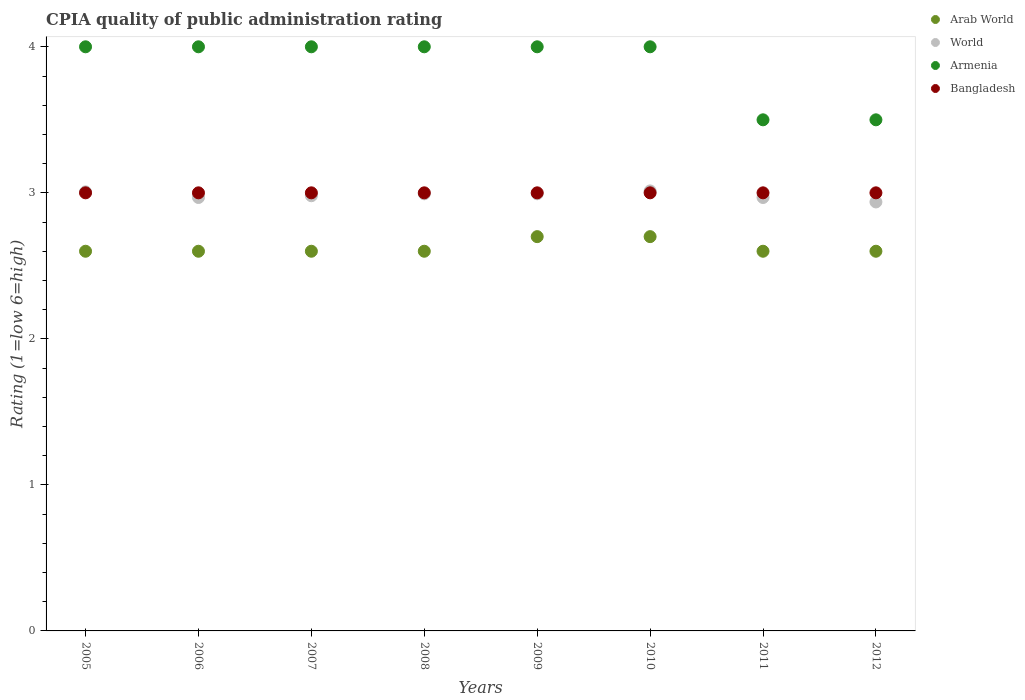How many different coloured dotlines are there?
Your answer should be compact. 4. Is the number of dotlines equal to the number of legend labels?
Give a very brief answer. Yes. What is the CPIA rating in Arab World in 2008?
Keep it short and to the point. 2.6. Across all years, what is the maximum CPIA rating in Bangladesh?
Ensure brevity in your answer.  3. What is the total CPIA rating in Arab World in the graph?
Offer a very short reply. 21. What is the difference between the CPIA rating in Bangladesh in 2006 and that in 2010?
Your answer should be compact. 0. What is the average CPIA rating in Arab World per year?
Keep it short and to the point. 2.62. In the year 2007, what is the difference between the CPIA rating in Bangladesh and CPIA rating in World?
Your response must be concise. 0.02. In how many years, is the CPIA rating in World greater than 3.4?
Your answer should be compact. 0. What is the ratio of the CPIA rating in World in 2005 to that in 2009?
Your answer should be very brief. 1. Is the CPIA rating in Armenia in 2007 less than that in 2010?
Offer a very short reply. No. What is the difference between the highest and the lowest CPIA rating in Bangladesh?
Ensure brevity in your answer.  0. In how many years, is the CPIA rating in Armenia greater than the average CPIA rating in Armenia taken over all years?
Make the answer very short. 6. Is the sum of the CPIA rating in Bangladesh in 2007 and 2012 greater than the maximum CPIA rating in Arab World across all years?
Your answer should be compact. Yes. Is it the case that in every year, the sum of the CPIA rating in Bangladesh and CPIA rating in World  is greater than the sum of CPIA rating in Arab World and CPIA rating in Armenia?
Make the answer very short. Yes. Does the CPIA rating in Arab World monotonically increase over the years?
Your answer should be compact. No. What is the difference between two consecutive major ticks on the Y-axis?
Offer a very short reply. 1. Where does the legend appear in the graph?
Keep it short and to the point. Top right. How many legend labels are there?
Your answer should be compact. 4. What is the title of the graph?
Keep it short and to the point. CPIA quality of public administration rating. Does "Costa Rica" appear as one of the legend labels in the graph?
Give a very brief answer. No. What is the label or title of the Y-axis?
Your response must be concise. Rating (1=low 6=high). What is the Rating (1=low 6=high) in Arab World in 2005?
Your answer should be very brief. 2.6. What is the Rating (1=low 6=high) of World in 2005?
Provide a short and direct response. 3.01. What is the Rating (1=low 6=high) in Armenia in 2005?
Provide a succinct answer. 4. What is the Rating (1=low 6=high) of World in 2006?
Your answer should be very brief. 2.97. What is the Rating (1=low 6=high) in Armenia in 2006?
Offer a very short reply. 4. What is the Rating (1=low 6=high) in Bangladesh in 2006?
Offer a terse response. 3. What is the Rating (1=low 6=high) in World in 2007?
Offer a very short reply. 2.98. What is the Rating (1=low 6=high) in Arab World in 2008?
Ensure brevity in your answer.  2.6. What is the Rating (1=low 6=high) of World in 2008?
Your answer should be very brief. 2.99. What is the Rating (1=low 6=high) of Armenia in 2008?
Your response must be concise. 4. What is the Rating (1=low 6=high) of World in 2009?
Provide a succinct answer. 2.99. What is the Rating (1=low 6=high) in Arab World in 2010?
Provide a succinct answer. 2.7. What is the Rating (1=low 6=high) in World in 2010?
Your answer should be very brief. 3.01. What is the Rating (1=low 6=high) in Bangladesh in 2010?
Offer a very short reply. 3. What is the Rating (1=low 6=high) in Arab World in 2011?
Your answer should be compact. 2.6. What is the Rating (1=low 6=high) in World in 2011?
Your answer should be compact. 2.97. What is the Rating (1=low 6=high) in Bangladesh in 2011?
Give a very brief answer. 3. What is the Rating (1=low 6=high) in Arab World in 2012?
Provide a succinct answer. 2.6. What is the Rating (1=low 6=high) in World in 2012?
Ensure brevity in your answer.  2.94. What is the Rating (1=low 6=high) in Armenia in 2012?
Keep it short and to the point. 3.5. What is the Rating (1=low 6=high) in Bangladesh in 2012?
Offer a very short reply. 3. Across all years, what is the maximum Rating (1=low 6=high) of Arab World?
Your answer should be compact. 2.7. Across all years, what is the maximum Rating (1=low 6=high) in World?
Your answer should be very brief. 3.01. Across all years, what is the maximum Rating (1=low 6=high) of Armenia?
Your response must be concise. 4. Across all years, what is the minimum Rating (1=low 6=high) of World?
Make the answer very short. 2.94. What is the total Rating (1=low 6=high) of Arab World in the graph?
Your answer should be very brief. 21. What is the total Rating (1=low 6=high) of World in the graph?
Your answer should be compact. 23.86. What is the total Rating (1=low 6=high) in Armenia in the graph?
Your response must be concise. 31. What is the total Rating (1=low 6=high) of Bangladesh in the graph?
Ensure brevity in your answer.  24. What is the difference between the Rating (1=low 6=high) in Arab World in 2005 and that in 2006?
Keep it short and to the point. 0. What is the difference between the Rating (1=low 6=high) of World in 2005 and that in 2006?
Keep it short and to the point. 0.04. What is the difference between the Rating (1=low 6=high) of Armenia in 2005 and that in 2006?
Your answer should be compact. 0. What is the difference between the Rating (1=low 6=high) of Bangladesh in 2005 and that in 2006?
Offer a terse response. 0. What is the difference between the Rating (1=low 6=high) of World in 2005 and that in 2007?
Keep it short and to the point. 0.03. What is the difference between the Rating (1=low 6=high) in Arab World in 2005 and that in 2008?
Provide a short and direct response. 0. What is the difference between the Rating (1=low 6=high) of World in 2005 and that in 2008?
Your answer should be very brief. 0.01. What is the difference between the Rating (1=low 6=high) of Armenia in 2005 and that in 2008?
Ensure brevity in your answer.  0. What is the difference between the Rating (1=low 6=high) in Bangladesh in 2005 and that in 2008?
Ensure brevity in your answer.  0. What is the difference between the Rating (1=low 6=high) of World in 2005 and that in 2009?
Provide a short and direct response. 0.01. What is the difference between the Rating (1=low 6=high) in Armenia in 2005 and that in 2009?
Provide a short and direct response. 0. What is the difference between the Rating (1=low 6=high) in Bangladesh in 2005 and that in 2009?
Make the answer very short. 0. What is the difference between the Rating (1=low 6=high) in World in 2005 and that in 2010?
Keep it short and to the point. -0.01. What is the difference between the Rating (1=low 6=high) of Bangladesh in 2005 and that in 2010?
Make the answer very short. 0. What is the difference between the Rating (1=low 6=high) in Arab World in 2005 and that in 2011?
Offer a terse response. 0. What is the difference between the Rating (1=low 6=high) of World in 2005 and that in 2011?
Make the answer very short. 0.04. What is the difference between the Rating (1=low 6=high) of Armenia in 2005 and that in 2011?
Offer a terse response. 0.5. What is the difference between the Rating (1=low 6=high) in Bangladesh in 2005 and that in 2011?
Ensure brevity in your answer.  0. What is the difference between the Rating (1=low 6=high) of Arab World in 2005 and that in 2012?
Your response must be concise. 0. What is the difference between the Rating (1=low 6=high) of World in 2005 and that in 2012?
Provide a short and direct response. 0.07. What is the difference between the Rating (1=low 6=high) in Armenia in 2005 and that in 2012?
Provide a succinct answer. 0.5. What is the difference between the Rating (1=low 6=high) of Bangladesh in 2005 and that in 2012?
Provide a short and direct response. 0. What is the difference between the Rating (1=low 6=high) in World in 2006 and that in 2007?
Offer a very short reply. -0.01. What is the difference between the Rating (1=low 6=high) of World in 2006 and that in 2008?
Make the answer very short. -0.03. What is the difference between the Rating (1=low 6=high) in Armenia in 2006 and that in 2008?
Make the answer very short. 0. What is the difference between the Rating (1=low 6=high) of Bangladesh in 2006 and that in 2008?
Your response must be concise. 0. What is the difference between the Rating (1=low 6=high) in World in 2006 and that in 2009?
Make the answer very short. -0.03. What is the difference between the Rating (1=low 6=high) of Arab World in 2006 and that in 2010?
Provide a short and direct response. -0.1. What is the difference between the Rating (1=low 6=high) of World in 2006 and that in 2010?
Give a very brief answer. -0.04. What is the difference between the Rating (1=low 6=high) of Bangladesh in 2006 and that in 2011?
Give a very brief answer. 0. What is the difference between the Rating (1=low 6=high) in Arab World in 2006 and that in 2012?
Give a very brief answer. 0. What is the difference between the Rating (1=low 6=high) of World in 2006 and that in 2012?
Offer a terse response. 0.03. What is the difference between the Rating (1=low 6=high) in World in 2007 and that in 2008?
Keep it short and to the point. -0.01. What is the difference between the Rating (1=low 6=high) in Armenia in 2007 and that in 2008?
Provide a succinct answer. 0. What is the difference between the Rating (1=low 6=high) in Bangladesh in 2007 and that in 2008?
Ensure brevity in your answer.  0. What is the difference between the Rating (1=low 6=high) in World in 2007 and that in 2009?
Ensure brevity in your answer.  -0.01. What is the difference between the Rating (1=low 6=high) of Armenia in 2007 and that in 2009?
Make the answer very short. 0. What is the difference between the Rating (1=low 6=high) of Bangladesh in 2007 and that in 2009?
Give a very brief answer. 0. What is the difference between the Rating (1=low 6=high) of World in 2007 and that in 2010?
Your response must be concise. -0.03. What is the difference between the Rating (1=low 6=high) of Armenia in 2007 and that in 2010?
Your answer should be compact. 0. What is the difference between the Rating (1=low 6=high) in Bangladesh in 2007 and that in 2010?
Your answer should be very brief. 0. What is the difference between the Rating (1=low 6=high) of World in 2007 and that in 2011?
Your answer should be compact. 0.01. What is the difference between the Rating (1=low 6=high) in Bangladesh in 2007 and that in 2011?
Provide a short and direct response. 0. What is the difference between the Rating (1=low 6=high) in World in 2007 and that in 2012?
Provide a succinct answer. 0.04. What is the difference between the Rating (1=low 6=high) in Armenia in 2007 and that in 2012?
Your response must be concise. 0.5. What is the difference between the Rating (1=low 6=high) in Arab World in 2008 and that in 2009?
Your answer should be compact. -0.1. What is the difference between the Rating (1=low 6=high) of World in 2008 and that in 2009?
Give a very brief answer. -0. What is the difference between the Rating (1=low 6=high) in Armenia in 2008 and that in 2009?
Give a very brief answer. 0. What is the difference between the Rating (1=low 6=high) of World in 2008 and that in 2010?
Keep it short and to the point. -0.02. What is the difference between the Rating (1=low 6=high) of Arab World in 2008 and that in 2011?
Provide a short and direct response. 0. What is the difference between the Rating (1=low 6=high) of World in 2008 and that in 2011?
Ensure brevity in your answer.  0.03. What is the difference between the Rating (1=low 6=high) of Armenia in 2008 and that in 2011?
Provide a succinct answer. 0.5. What is the difference between the Rating (1=low 6=high) in Bangladesh in 2008 and that in 2011?
Keep it short and to the point. 0. What is the difference between the Rating (1=low 6=high) of World in 2008 and that in 2012?
Offer a very short reply. 0.06. What is the difference between the Rating (1=low 6=high) in Arab World in 2009 and that in 2010?
Give a very brief answer. 0. What is the difference between the Rating (1=low 6=high) of World in 2009 and that in 2010?
Ensure brevity in your answer.  -0.02. What is the difference between the Rating (1=low 6=high) in Armenia in 2009 and that in 2010?
Offer a very short reply. 0. What is the difference between the Rating (1=low 6=high) in Arab World in 2009 and that in 2011?
Offer a very short reply. 0.1. What is the difference between the Rating (1=low 6=high) of World in 2009 and that in 2011?
Ensure brevity in your answer.  0.03. What is the difference between the Rating (1=low 6=high) in World in 2009 and that in 2012?
Your answer should be very brief. 0.06. What is the difference between the Rating (1=low 6=high) in Bangladesh in 2009 and that in 2012?
Give a very brief answer. 0. What is the difference between the Rating (1=low 6=high) of Arab World in 2010 and that in 2011?
Give a very brief answer. 0.1. What is the difference between the Rating (1=low 6=high) in World in 2010 and that in 2011?
Offer a terse response. 0.04. What is the difference between the Rating (1=low 6=high) in World in 2010 and that in 2012?
Provide a short and direct response. 0.08. What is the difference between the Rating (1=low 6=high) of Arab World in 2011 and that in 2012?
Your answer should be compact. 0. What is the difference between the Rating (1=low 6=high) of World in 2011 and that in 2012?
Make the answer very short. 0.03. What is the difference between the Rating (1=low 6=high) of Armenia in 2011 and that in 2012?
Keep it short and to the point. 0. What is the difference between the Rating (1=low 6=high) of Arab World in 2005 and the Rating (1=low 6=high) of World in 2006?
Make the answer very short. -0.37. What is the difference between the Rating (1=low 6=high) of Arab World in 2005 and the Rating (1=low 6=high) of Armenia in 2006?
Your answer should be compact. -1.4. What is the difference between the Rating (1=low 6=high) of World in 2005 and the Rating (1=low 6=high) of Armenia in 2006?
Your answer should be very brief. -0.99. What is the difference between the Rating (1=low 6=high) in World in 2005 and the Rating (1=low 6=high) in Bangladesh in 2006?
Your response must be concise. 0.01. What is the difference between the Rating (1=low 6=high) of Armenia in 2005 and the Rating (1=low 6=high) of Bangladesh in 2006?
Provide a short and direct response. 1. What is the difference between the Rating (1=low 6=high) of Arab World in 2005 and the Rating (1=low 6=high) of World in 2007?
Ensure brevity in your answer.  -0.38. What is the difference between the Rating (1=low 6=high) in Arab World in 2005 and the Rating (1=low 6=high) in Armenia in 2007?
Your answer should be compact. -1.4. What is the difference between the Rating (1=low 6=high) in Arab World in 2005 and the Rating (1=low 6=high) in Bangladesh in 2007?
Keep it short and to the point. -0.4. What is the difference between the Rating (1=low 6=high) of World in 2005 and the Rating (1=low 6=high) of Armenia in 2007?
Your response must be concise. -0.99. What is the difference between the Rating (1=low 6=high) of World in 2005 and the Rating (1=low 6=high) of Bangladesh in 2007?
Offer a terse response. 0.01. What is the difference between the Rating (1=low 6=high) in Armenia in 2005 and the Rating (1=low 6=high) in Bangladesh in 2007?
Ensure brevity in your answer.  1. What is the difference between the Rating (1=low 6=high) in Arab World in 2005 and the Rating (1=low 6=high) in World in 2008?
Your answer should be compact. -0.39. What is the difference between the Rating (1=low 6=high) of Arab World in 2005 and the Rating (1=low 6=high) of Bangladesh in 2008?
Ensure brevity in your answer.  -0.4. What is the difference between the Rating (1=low 6=high) of World in 2005 and the Rating (1=low 6=high) of Armenia in 2008?
Keep it short and to the point. -0.99. What is the difference between the Rating (1=low 6=high) in World in 2005 and the Rating (1=low 6=high) in Bangladesh in 2008?
Keep it short and to the point. 0.01. What is the difference between the Rating (1=low 6=high) of Arab World in 2005 and the Rating (1=low 6=high) of World in 2009?
Provide a short and direct response. -0.39. What is the difference between the Rating (1=low 6=high) of Arab World in 2005 and the Rating (1=low 6=high) of Armenia in 2009?
Keep it short and to the point. -1.4. What is the difference between the Rating (1=low 6=high) of World in 2005 and the Rating (1=low 6=high) of Armenia in 2009?
Offer a very short reply. -0.99. What is the difference between the Rating (1=low 6=high) in World in 2005 and the Rating (1=low 6=high) in Bangladesh in 2009?
Provide a short and direct response. 0.01. What is the difference between the Rating (1=low 6=high) of Arab World in 2005 and the Rating (1=low 6=high) of World in 2010?
Provide a short and direct response. -0.41. What is the difference between the Rating (1=low 6=high) in Arab World in 2005 and the Rating (1=low 6=high) in Bangladesh in 2010?
Ensure brevity in your answer.  -0.4. What is the difference between the Rating (1=low 6=high) in World in 2005 and the Rating (1=low 6=high) in Armenia in 2010?
Make the answer very short. -0.99. What is the difference between the Rating (1=low 6=high) in World in 2005 and the Rating (1=low 6=high) in Bangladesh in 2010?
Your answer should be compact. 0.01. What is the difference between the Rating (1=low 6=high) in Arab World in 2005 and the Rating (1=low 6=high) in World in 2011?
Your response must be concise. -0.37. What is the difference between the Rating (1=low 6=high) in Arab World in 2005 and the Rating (1=low 6=high) in Armenia in 2011?
Give a very brief answer. -0.9. What is the difference between the Rating (1=low 6=high) in Arab World in 2005 and the Rating (1=low 6=high) in Bangladesh in 2011?
Your answer should be compact. -0.4. What is the difference between the Rating (1=low 6=high) of World in 2005 and the Rating (1=low 6=high) of Armenia in 2011?
Your answer should be very brief. -0.49. What is the difference between the Rating (1=low 6=high) in World in 2005 and the Rating (1=low 6=high) in Bangladesh in 2011?
Offer a terse response. 0.01. What is the difference between the Rating (1=low 6=high) in Armenia in 2005 and the Rating (1=low 6=high) in Bangladesh in 2011?
Offer a terse response. 1. What is the difference between the Rating (1=low 6=high) of Arab World in 2005 and the Rating (1=low 6=high) of World in 2012?
Make the answer very short. -0.34. What is the difference between the Rating (1=low 6=high) of World in 2005 and the Rating (1=low 6=high) of Armenia in 2012?
Offer a very short reply. -0.49. What is the difference between the Rating (1=low 6=high) in World in 2005 and the Rating (1=low 6=high) in Bangladesh in 2012?
Offer a terse response. 0.01. What is the difference between the Rating (1=low 6=high) in Arab World in 2006 and the Rating (1=low 6=high) in World in 2007?
Provide a short and direct response. -0.38. What is the difference between the Rating (1=low 6=high) in Arab World in 2006 and the Rating (1=low 6=high) in Armenia in 2007?
Give a very brief answer. -1.4. What is the difference between the Rating (1=low 6=high) of Arab World in 2006 and the Rating (1=low 6=high) of Bangladesh in 2007?
Keep it short and to the point. -0.4. What is the difference between the Rating (1=low 6=high) of World in 2006 and the Rating (1=low 6=high) of Armenia in 2007?
Keep it short and to the point. -1.03. What is the difference between the Rating (1=low 6=high) in World in 2006 and the Rating (1=low 6=high) in Bangladesh in 2007?
Provide a succinct answer. -0.03. What is the difference between the Rating (1=low 6=high) in Armenia in 2006 and the Rating (1=low 6=high) in Bangladesh in 2007?
Offer a terse response. 1. What is the difference between the Rating (1=low 6=high) of Arab World in 2006 and the Rating (1=low 6=high) of World in 2008?
Your response must be concise. -0.39. What is the difference between the Rating (1=low 6=high) in Arab World in 2006 and the Rating (1=low 6=high) in Armenia in 2008?
Offer a very short reply. -1.4. What is the difference between the Rating (1=low 6=high) in World in 2006 and the Rating (1=low 6=high) in Armenia in 2008?
Your answer should be compact. -1.03. What is the difference between the Rating (1=low 6=high) of World in 2006 and the Rating (1=low 6=high) of Bangladesh in 2008?
Offer a very short reply. -0.03. What is the difference between the Rating (1=low 6=high) of Arab World in 2006 and the Rating (1=low 6=high) of World in 2009?
Keep it short and to the point. -0.39. What is the difference between the Rating (1=low 6=high) in Arab World in 2006 and the Rating (1=low 6=high) in Armenia in 2009?
Your answer should be compact. -1.4. What is the difference between the Rating (1=low 6=high) in Arab World in 2006 and the Rating (1=low 6=high) in Bangladesh in 2009?
Offer a terse response. -0.4. What is the difference between the Rating (1=low 6=high) of World in 2006 and the Rating (1=low 6=high) of Armenia in 2009?
Your answer should be very brief. -1.03. What is the difference between the Rating (1=low 6=high) of World in 2006 and the Rating (1=low 6=high) of Bangladesh in 2009?
Give a very brief answer. -0.03. What is the difference between the Rating (1=low 6=high) in Arab World in 2006 and the Rating (1=low 6=high) in World in 2010?
Provide a succinct answer. -0.41. What is the difference between the Rating (1=low 6=high) of Arab World in 2006 and the Rating (1=low 6=high) of Armenia in 2010?
Ensure brevity in your answer.  -1.4. What is the difference between the Rating (1=low 6=high) of Arab World in 2006 and the Rating (1=low 6=high) of Bangladesh in 2010?
Make the answer very short. -0.4. What is the difference between the Rating (1=low 6=high) of World in 2006 and the Rating (1=low 6=high) of Armenia in 2010?
Keep it short and to the point. -1.03. What is the difference between the Rating (1=low 6=high) of World in 2006 and the Rating (1=low 6=high) of Bangladesh in 2010?
Provide a short and direct response. -0.03. What is the difference between the Rating (1=low 6=high) of Arab World in 2006 and the Rating (1=low 6=high) of World in 2011?
Ensure brevity in your answer.  -0.37. What is the difference between the Rating (1=low 6=high) in Arab World in 2006 and the Rating (1=low 6=high) in Bangladesh in 2011?
Provide a succinct answer. -0.4. What is the difference between the Rating (1=low 6=high) in World in 2006 and the Rating (1=low 6=high) in Armenia in 2011?
Give a very brief answer. -0.53. What is the difference between the Rating (1=low 6=high) of World in 2006 and the Rating (1=low 6=high) of Bangladesh in 2011?
Keep it short and to the point. -0.03. What is the difference between the Rating (1=low 6=high) in Armenia in 2006 and the Rating (1=low 6=high) in Bangladesh in 2011?
Make the answer very short. 1. What is the difference between the Rating (1=low 6=high) of Arab World in 2006 and the Rating (1=low 6=high) of World in 2012?
Your answer should be very brief. -0.34. What is the difference between the Rating (1=low 6=high) of Arab World in 2006 and the Rating (1=low 6=high) of Bangladesh in 2012?
Keep it short and to the point. -0.4. What is the difference between the Rating (1=low 6=high) of World in 2006 and the Rating (1=low 6=high) of Armenia in 2012?
Make the answer very short. -0.53. What is the difference between the Rating (1=low 6=high) in World in 2006 and the Rating (1=low 6=high) in Bangladesh in 2012?
Offer a very short reply. -0.03. What is the difference between the Rating (1=low 6=high) in Arab World in 2007 and the Rating (1=low 6=high) in World in 2008?
Provide a succinct answer. -0.39. What is the difference between the Rating (1=low 6=high) in Arab World in 2007 and the Rating (1=low 6=high) in Armenia in 2008?
Your answer should be compact. -1.4. What is the difference between the Rating (1=low 6=high) in World in 2007 and the Rating (1=low 6=high) in Armenia in 2008?
Provide a succinct answer. -1.02. What is the difference between the Rating (1=low 6=high) of World in 2007 and the Rating (1=low 6=high) of Bangladesh in 2008?
Offer a terse response. -0.02. What is the difference between the Rating (1=low 6=high) of Armenia in 2007 and the Rating (1=low 6=high) of Bangladesh in 2008?
Offer a terse response. 1. What is the difference between the Rating (1=low 6=high) of Arab World in 2007 and the Rating (1=low 6=high) of World in 2009?
Ensure brevity in your answer.  -0.39. What is the difference between the Rating (1=low 6=high) in Arab World in 2007 and the Rating (1=low 6=high) in Bangladesh in 2009?
Give a very brief answer. -0.4. What is the difference between the Rating (1=low 6=high) of World in 2007 and the Rating (1=low 6=high) of Armenia in 2009?
Your answer should be very brief. -1.02. What is the difference between the Rating (1=low 6=high) of World in 2007 and the Rating (1=low 6=high) of Bangladesh in 2009?
Give a very brief answer. -0.02. What is the difference between the Rating (1=low 6=high) of Arab World in 2007 and the Rating (1=low 6=high) of World in 2010?
Provide a short and direct response. -0.41. What is the difference between the Rating (1=low 6=high) of World in 2007 and the Rating (1=low 6=high) of Armenia in 2010?
Your answer should be very brief. -1.02. What is the difference between the Rating (1=low 6=high) of World in 2007 and the Rating (1=low 6=high) of Bangladesh in 2010?
Make the answer very short. -0.02. What is the difference between the Rating (1=low 6=high) of Armenia in 2007 and the Rating (1=low 6=high) of Bangladesh in 2010?
Ensure brevity in your answer.  1. What is the difference between the Rating (1=low 6=high) of Arab World in 2007 and the Rating (1=low 6=high) of World in 2011?
Your answer should be very brief. -0.37. What is the difference between the Rating (1=low 6=high) in Arab World in 2007 and the Rating (1=low 6=high) in Bangladesh in 2011?
Provide a short and direct response. -0.4. What is the difference between the Rating (1=low 6=high) in World in 2007 and the Rating (1=low 6=high) in Armenia in 2011?
Ensure brevity in your answer.  -0.52. What is the difference between the Rating (1=low 6=high) in World in 2007 and the Rating (1=low 6=high) in Bangladesh in 2011?
Give a very brief answer. -0.02. What is the difference between the Rating (1=low 6=high) in Armenia in 2007 and the Rating (1=low 6=high) in Bangladesh in 2011?
Your answer should be very brief. 1. What is the difference between the Rating (1=low 6=high) of Arab World in 2007 and the Rating (1=low 6=high) of World in 2012?
Your response must be concise. -0.34. What is the difference between the Rating (1=low 6=high) of World in 2007 and the Rating (1=low 6=high) of Armenia in 2012?
Offer a terse response. -0.52. What is the difference between the Rating (1=low 6=high) of World in 2007 and the Rating (1=low 6=high) of Bangladesh in 2012?
Make the answer very short. -0.02. What is the difference between the Rating (1=low 6=high) of Arab World in 2008 and the Rating (1=low 6=high) of World in 2009?
Ensure brevity in your answer.  -0.39. What is the difference between the Rating (1=low 6=high) of World in 2008 and the Rating (1=low 6=high) of Armenia in 2009?
Provide a succinct answer. -1.01. What is the difference between the Rating (1=low 6=high) in World in 2008 and the Rating (1=low 6=high) in Bangladesh in 2009?
Offer a terse response. -0.01. What is the difference between the Rating (1=low 6=high) in Armenia in 2008 and the Rating (1=low 6=high) in Bangladesh in 2009?
Provide a short and direct response. 1. What is the difference between the Rating (1=low 6=high) of Arab World in 2008 and the Rating (1=low 6=high) of World in 2010?
Give a very brief answer. -0.41. What is the difference between the Rating (1=low 6=high) in Arab World in 2008 and the Rating (1=low 6=high) in Bangladesh in 2010?
Provide a short and direct response. -0.4. What is the difference between the Rating (1=low 6=high) in World in 2008 and the Rating (1=low 6=high) in Armenia in 2010?
Your answer should be compact. -1.01. What is the difference between the Rating (1=low 6=high) in World in 2008 and the Rating (1=low 6=high) in Bangladesh in 2010?
Offer a very short reply. -0.01. What is the difference between the Rating (1=low 6=high) of Armenia in 2008 and the Rating (1=low 6=high) of Bangladesh in 2010?
Your answer should be very brief. 1. What is the difference between the Rating (1=low 6=high) of Arab World in 2008 and the Rating (1=low 6=high) of World in 2011?
Offer a very short reply. -0.37. What is the difference between the Rating (1=low 6=high) of World in 2008 and the Rating (1=low 6=high) of Armenia in 2011?
Offer a terse response. -0.51. What is the difference between the Rating (1=low 6=high) in World in 2008 and the Rating (1=low 6=high) in Bangladesh in 2011?
Make the answer very short. -0.01. What is the difference between the Rating (1=low 6=high) in Arab World in 2008 and the Rating (1=low 6=high) in World in 2012?
Give a very brief answer. -0.34. What is the difference between the Rating (1=low 6=high) in Arab World in 2008 and the Rating (1=low 6=high) in Bangladesh in 2012?
Offer a very short reply. -0.4. What is the difference between the Rating (1=low 6=high) in World in 2008 and the Rating (1=low 6=high) in Armenia in 2012?
Keep it short and to the point. -0.51. What is the difference between the Rating (1=low 6=high) in World in 2008 and the Rating (1=low 6=high) in Bangladesh in 2012?
Give a very brief answer. -0.01. What is the difference between the Rating (1=low 6=high) in Arab World in 2009 and the Rating (1=low 6=high) in World in 2010?
Your answer should be compact. -0.31. What is the difference between the Rating (1=low 6=high) in World in 2009 and the Rating (1=low 6=high) in Armenia in 2010?
Ensure brevity in your answer.  -1.01. What is the difference between the Rating (1=low 6=high) in World in 2009 and the Rating (1=low 6=high) in Bangladesh in 2010?
Ensure brevity in your answer.  -0.01. What is the difference between the Rating (1=low 6=high) in Armenia in 2009 and the Rating (1=low 6=high) in Bangladesh in 2010?
Provide a succinct answer. 1. What is the difference between the Rating (1=low 6=high) in Arab World in 2009 and the Rating (1=low 6=high) in World in 2011?
Provide a short and direct response. -0.27. What is the difference between the Rating (1=low 6=high) of Arab World in 2009 and the Rating (1=low 6=high) of Bangladesh in 2011?
Your answer should be compact. -0.3. What is the difference between the Rating (1=low 6=high) in World in 2009 and the Rating (1=low 6=high) in Armenia in 2011?
Keep it short and to the point. -0.51. What is the difference between the Rating (1=low 6=high) in World in 2009 and the Rating (1=low 6=high) in Bangladesh in 2011?
Provide a succinct answer. -0.01. What is the difference between the Rating (1=low 6=high) of Arab World in 2009 and the Rating (1=low 6=high) of World in 2012?
Your answer should be compact. -0.24. What is the difference between the Rating (1=low 6=high) of Arab World in 2009 and the Rating (1=low 6=high) of Armenia in 2012?
Give a very brief answer. -0.8. What is the difference between the Rating (1=low 6=high) in Arab World in 2009 and the Rating (1=low 6=high) in Bangladesh in 2012?
Keep it short and to the point. -0.3. What is the difference between the Rating (1=low 6=high) in World in 2009 and the Rating (1=low 6=high) in Armenia in 2012?
Keep it short and to the point. -0.51. What is the difference between the Rating (1=low 6=high) in World in 2009 and the Rating (1=low 6=high) in Bangladesh in 2012?
Keep it short and to the point. -0.01. What is the difference between the Rating (1=low 6=high) in Arab World in 2010 and the Rating (1=low 6=high) in World in 2011?
Offer a very short reply. -0.27. What is the difference between the Rating (1=low 6=high) in World in 2010 and the Rating (1=low 6=high) in Armenia in 2011?
Make the answer very short. -0.49. What is the difference between the Rating (1=low 6=high) of World in 2010 and the Rating (1=low 6=high) of Bangladesh in 2011?
Offer a very short reply. 0.01. What is the difference between the Rating (1=low 6=high) of Armenia in 2010 and the Rating (1=low 6=high) of Bangladesh in 2011?
Provide a short and direct response. 1. What is the difference between the Rating (1=low 6=high) in Arab World in 2010 and the Rating (1=low 6=high) in World in 2012?
Give a very brief answer. -0.24. What is the difference between the Rating (1=low 6=high) in World in 2010 and the Rating (1=low 6=high) in Armenia in 2012?
Your answer should be compact. -0.49. What is the difference between the Rating (1=low 6=high) of World in 2010 and the Rating (1=low 6=high) of Bangladesh in 2012?
Keep it short and to the point. 0.01. What is the difference between the Rating (1=low 6=high) of Arab World in 2011 and the Rating (1=low 6=high) of World in 2012?
Keep it short and to the point. -0.34. What is the difference between the Rating (1=low 6=high) of Arab World in 2011 and the Rating (1=low 6=high) of Bangladesh in 2012?
Offer a terse response. -0.4. What is the difference between the Rating (1=low 6=high) in World in 2011 and the Rating (1=low 6=high) in Armenia in 2012?
Provide a succinct answer. -0.53. What is the difference between the Rating (1=low 6=high) in World in 2011 and the Rating (1=low 6=high) in Bangladesh in 2012?
Your answer should be very brief. -0.03. What is the average Rating (1=low 6=high) in Arab World per year?
Keep it short and to the point. 2.62. What is the average Rating (1=low 6=high) in World per year?
Ensure brevity in your answer.  2.98. What is the average Rating (1=low 6=high) in Armenia per year?
Ensure brevity in your answer.  3.88. In the year 2005, what is the difference between the Rating (1=low 6=high) in Arab World and Rating (1=low 6=high) in World?
Your answer should be very brief. -0.41. In the year 2005, what is the difference between the Rating (1=low 6=high) in World and Rating (1=low 6=high) in Armenia?
Keep it short and to the point. -0.99. In the year 2005, what is the difference between the Rating (1=low 6=high) of World and Rating (1=low 6=high) of Bangladesh?
Keep it short and to the point. 0.01. In the year 2006, what is the difference between the Rating (1=low 6=high) of Arab World and Rating (1=low 6=high) of World?
Give a very brief answer. -0.37. In the year 2006, what is the difference between the Rating (1=low 6=high) of Arab World and Rating (1=low 6=high) of Armenia?
Your answer should be compact. -1.4. In the year 2006, what is the difference between the Rating (1=low 6=high) in World and Rating (1=low 6=high) in Armenia?
Your answer should be very brief. -1.03. In the year 2006, what is the difference between the Rating (1=low 6=high) in World and Rating (1=low 6=high) in Bangladesh?
Make the answer very short. -0.03. In the year 2006, what is the difference between the Rating (1=low 6=high) in Armenia and Rating (1=low 6=high) in Bangladesh?
Your answer should be very brief. 1. In the year 2007, what is the difference between the Rating (1=low 6=high) of Arab World and Rating (1=low 6=high) of World?
Your answer should be compact. -0.38. In the year 2007, what is the difference between the Rating (1=low 6=high) of Arab World and Rating (1=low 6=high) of Bangladesh?
Your answer should be compact. -0.4. In the year 2007, what is the difference between the Rating (1=low 6=high) of World and Rating (1=low 6=high) of Armenia?
Ensure brevity in your answer.  -1.02. In the year 2007, what is the difference between the Rating (1=low 6=high) of World and Rating (1=low 6=high) of Bangladesh?
Offer a very short reply. -0.02. In the year 2008, what is the difference between the Rating (1=low 6=high) in Arab World and Rating (1=low 6=high) in World?
Ensure brevity in your answer.  -0.39. In the year 2008, what is the difference between the Rating (1=low 6=high) of Arab World and Rating (1=low 6=high) of Armenia?
Ensure brevity in your answer.  -1.4. In the year 2008, what is the difference between the Rating (1=low 6=high) in Arab World and Rating (1=low 6=high) in Bangladesh?
Ensure brevity in your answer.  -0.4. In the year 2008, what is the difference between the Rating (1=low 6=high) of World and Rating (1=low 6=high) of Armenia?
Keep it short and to the point. -1.01. In the year 2008, what is the difference between the Rating (1=low 6=high) in World and Rating (1=low 6=high) in Bangladesh?
Offer a very short reply. -0.01. In the year 2008, what is the difference between the Rating (1=low 6=high) in Armenia and Rating (1=low 6=high) in Bangladesh?
Your response must be concise. 1. In the year 2009, what is the difference between the Rating (1=low 6=high) of Arab World and Rating (1=low 6=high) of World?
Make the answer very short. -0.29. In the year 2009, what is the difference between the Rating (1=low 6=high) of World and Rating (1=low 6=high) of Armenia?
Your response must be concise. -1.01. In the year 2009, what is the difference between the Rating (1=low 6=high) in World and Rating (1=low 6=high) in Bangladesh?
Provide a succinct answer. -0.01. In the year 2010, what is the difference between the Rating (1=low 6=high) in Arab World and Rating (1=low 6=high) in World?
Provide a short and direct response. -0.31. In the year 2010, what is the difference between the Rating (1=low 6=high) of Arab World and Rating (1=low 6=high) of Armenia?
Provide a short and direct response. -1.3. In the year 2010, what is the difference between the Rating (1=low 6=high) in Arab World and Rating (1=low 6=high) in Bangladesh?
Your response must be concise. -0.3. In the year 2010, what is the difference between the Rating (1=low 6=high) in World and Rating (1=low 6=high) in Armenia?
Your answer should be compact. -0.99. In the year 2010, what is the difference between the Rating (1=low 6=high) in World and Rating (1=low 6=high) in Bangladesh?
Your response must be concise. 0.01. In the year 2010, what is the difference between the Rating (1=low 6=high) of Armenia and Rating (1=low 6=high) of Bangladesh?
Your response must be concise. 1. In the year 2011, what is the difference between the Rating (1=low 6=high) of Arab World and Rating (1=low 6=high) of World?
Provide a short and direct response. -0.37. In the year 2011, what is the difference between the Rating (1=low 6=high) of Arab World and Rating (1=low 6=high) of Armenia?
Your response must be concise. -0.9. In the year 2011, what is the difference between the Rating (1=low 6=high) of World and Rating (1=low 6=high) of Armenia?
Offer a terse response. -0.53. In the year 2011, what is the difference between the Rating (1=low 6=high) in World and Rating (1=low 6=high) in Bangladesh?
Provide a short and direct response. -0.03. In the year 2012, what is the difference between the Rating (1=low 6=high) in Arab World and Rating (1=low 6=high) in World?
Your response must be concise. -0.34. In the year 2012, what is the difference between the Rating (1=low 6=high) in World and Rating (1=low 6=high) in Armenia?
Ensure brevity in your answer.  -0.56. In the year 2012, what is the difference between the Rating (1=low 6=high) in World and Rating (1=low 6=high) in Bangladesh?
Give a very brief answer. -0.06. What is the ratio of the Rating (1=low 6=high) of Arab World in 2005 to that in 2006?
Offer a terse response. 1. What is the ratio of the Rating (1=low 6=high) in Arab World in 2005 to that in 2007?
Make the answer very short. 1. What is the ratio of the Rating (1=low 6=high) in World in 2005 to that in 2007?
Give a very brief answer. 1.01. What is the ratio of the Rating (1=low 6=high) of Arab World in 2005 to that in 2008?
Your answer should be very brief. 1. What is the ratio of the Rating (1=low 6=high) of World in 2005 to that in 2008?
Offer a very short reply. 1. What is the ratio of the Rating (1=low 6=high) in Armenia in 2005 to that in 2008?
Offer a very short reply. 1. What is the ratio of the Rating (1=low 6=high) of Bangladesh in 2005 to that in 2008?
Give a very brief answer. 1. What is the ratio of the Rating (1=low 6=high) of World in 2005 to that in 2009?
Offer a terse response. 1. What is the ratio of the Rating (1=low 6=high) of Armenia in 2005 to that in 2009?
Your response must be concise. 1. What is the ratio of the Rating (1=low 6=high) in Bangladesh in 2005 to that in 2010?
Your answer should be very brief. 1. What is the ratio of the Rating (1=low 6=high) of Arab World in 2005 to that in 2011?
Your answer should be very brief. 1. What is the ratio of the Rating (1=low 6=high) in Armenia in 2005 to that in 2011?
Make the answer very short. 1.14. What is the ratio of the Rating (1=low 6=high) of Bangladesh in 2005 to that in 2011?
Keep it short and to the point. 1. What is the ratio of the Rating (1=low 6=high) of Arab World in 2005 to that in 2012?
Keep it short and to the point. 1. What is the ratio of the Rating (1=low 6=high) in World in 2005 to that in 2012?
Keep it short and to the point. 1.02. What is the ratio of the Rating (1=low 6=high) in Bangladesh in 2005 to that in 2012?
Your answer should be very brief. 1. What is the ratio of the Rating (1=low 6=high) of Bangladesh in 2006 to that in 2007?
Your response must be concise. 1. What is the ratio of the Rating (1=low 6=high) in Armenia in 2006 to that in 2008?
Provide a succinct answer. 1. What is the ratio of the Rating (1=low 6=high) in Bangladesh in 2006 to that in 2008?
Provide a short and direct response. 1. What is the ratio of the Rating (1=low 6=high) of Armenia in 2006 to that in 2009?
Offer a terse response. 1. What is the ratio of the Rating (1=low 6=high) of World in 2006 to that in 2010?
Make the answer very short. 0.99. What is the ratio of the Rating (1=low 6=high) in Armenia in 2006 to that in 2010?
Keep it short and to the point. 1. What is the ratio of the Rating (1=low 6=high) of Bangladesh in 2006 to that in 2010?
Offer a very short reply. 1. What is the ratio of the Rating (1=low 6=high) in Arab World in 2006 to that in 2011?
Offer a very short reply. 1. What is the ratio of the Rating (1=low 6=high) of Armenia in 2006 to that in 2011?
Your response must be concise. 1.14. What is the ratio of the Rating (1=low 6=high) of Bangladesh in 2006 to that in 2011?
Provide a succinct answer. 1. What is the ratio of the Rating (1=low 6=high) of Arab World in 2006 to that in 2012?
Offer a terse response. 1. What is the ratio of the Rating (1=low 6=high) in World in 2006 to that in 2012?
Your answer should be compact. 1.01. What is the ratio of the Rating (1=low 6=high) of World in 2007 to that in 2008?
Your answer should be compact. 1. What is the ratio of the Rating (1=low 6=high) in Bangladesh in 2007 to that in 2008?
Your answer should be very brief. 1. What is the ratio of the Rating (1=low 6=high) of World in 2007 to that in 2010?
Ensure brevity in your answer.  0.99. What is the ratio of the Rating (1=low 6=high) of Armenia in 2007 to that in 2011?
Offer a very short reply. 1.14. What is the ratio of the Rating (1=low 6=high) in Bangladesh in 2007 to that in 2011?
Give a very brief answer. 1. What is the ratio of the Rating (1=low 6=high) in World in 2007 to that in 2012?
Make the answer very short. 1.01. What is the ratio of the Rating (1=low 6=high) in Armenia in 2007 to that in 2012?
Your answer should be very brief. 1.14. What is the ratio of the Rating (1=low 6=high) in Bangladesh in 2007 to that in 2012?
Your answer should be compact. 1. What is the ratio of the Rating (1=low 6=high) of Bangladesh in 2008 to that in 2009?
Your answer should be compact. 1. What is the ratio of the Rating (1=low 6=high) in Arab World in 2008 to that in 2010?
Your response must be concise. 0.96. What is the ratio of the Rating (1=low 6=high) of World in 2008 to that in 2010?
Your answer should be very brief. 0.99. What is the ratio of the Rating (1=low 6=high) in Arab World in 2008 to that in 2011?
Make the answer very short. 1. What is the ratio of the Rating (1=low 6=high) of World in 2008 to that in 2011?
Give a very brief answer. 1.01. What is the ratio of the Rating (1=low 6=high) in Armenia in 2008 to that in 2011?
Offer a terse response. 1.14. What is the ratio of the Rating (1=low 6=high) in Bangladesh in 2008 to that in 2011?
Make the answer very short. 1. What is the ratio of the Rating (1=low 6=high) in Arab World in 2008 to that in 2012?
Make the answer very short. 1. What is the ratio of the Rating (1=low 6=high) of Armenia in 2009 to that in 2010?
Provide a short and direct response. 1. What is the ratio of the Rating (1=low 6=high) of Arab World in 2009 to that in 2011?
Offer a very short reply. 1.04. What is the ratio of the Rating (1=low 6=high) of World in 2009 to that in 2011?
Your answer should be very brief. 1.01. What is the ratio of the Rating (1=low 6=high) in Armenia in 2009 to that in 2011?
Provide a short and direct response. 1.14. What is the ratio of the Rating (1=low 6=high) of Arab World in 2009 to that in 2012?
Provide a succinct answer. 1.04. What is the ratio of the Rating (1=low 6=high) of World in 2009 to that in 2012?
Keep it short and to the point. 1.02. What is the ratio of the Rating (1=low 6=high) of Armenia in 2009 to that in 2012?
Provide a short and direct response. 1.14. What is the ratio of the Rating (1=low 6=high) of Bangladesh in 2009 to that in 2012?
Make the answer very short. 1. What is the ratio of the Rating (1=low 6=high) of Arab World in 2010 to that in 2011?
Your response must be concise. 1.04. What is the ratio of the Rating (1=low 6=high) of World in 2010 to that in 2011?
Ensure brevity in your answer.  1.02. What is the ratio of the Rating (1=low 6=high) in Armenia in 2010 to that in 2011?
Offer a very short reply. 1.14. What is the ratio of the Rating (1=low 6=high) of Arab World in 2010 to that in 2012?
Provide a succinct answer. 1.04. What is the ratio of the Rating (1=low 6=high) of World in 2010 to that in 2012?
Offer a terse response. 1.03. What is the ratio of the Rating (1=low 6=high) in Arab World in 2011 to that in 2012?
Offer a very short reply. 1. What is the ratio of the Rating (1=low 6=high) in World in 2011 to that in 2012?
Keep it short and to the point. 1.01. What is the ratio of the Rating (1=low 6=high) of Armenia in 2011 to that in 2012?
Keep it short and to the point. 1. What is the difference between the highest and the second highest Rating (1=low 6=high) of World?
Offer a very short reply. 0.01. What is the difference between the highest and the lowest Rating (1=low 6=high) in World?
Offer a terse response. 0.08. What is the difference between the highest and the lowest Rating (1=low 6=high) in Armenia?
Offer a very short reply. 0.5. 